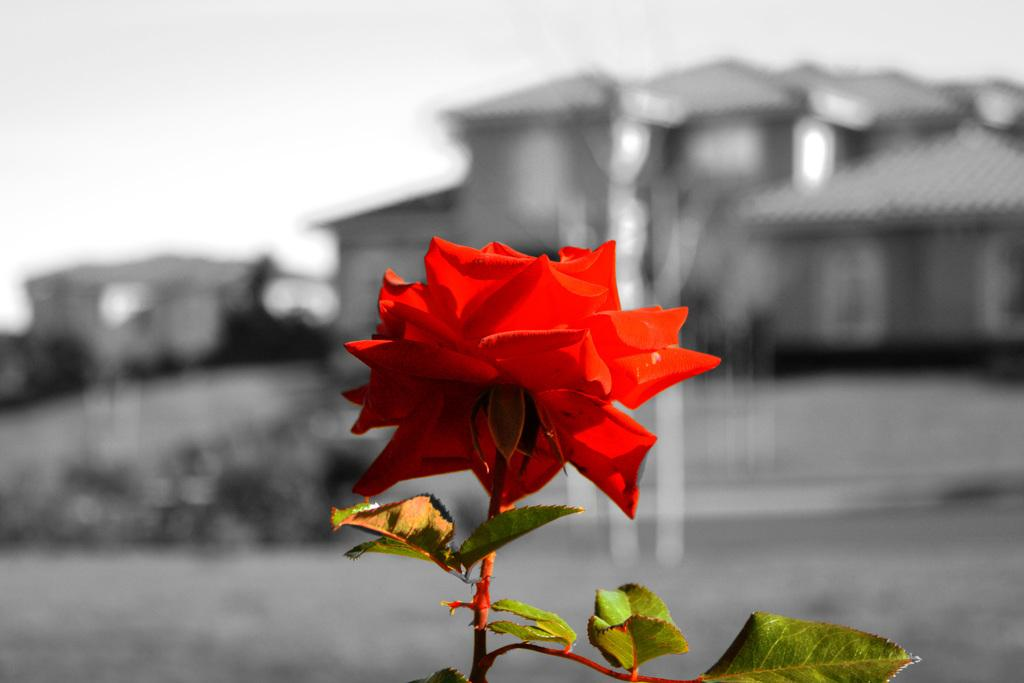What type of vegetation can be seen in the image? There are leaves in the image. What kind of flower is present in the image? There is a red color flower in the image. What can be seen in the distance in the image? There are houses in the background of the image. How would you describe the appearance of the background? The background appears blurry. What type of food is being served with a spoon in the image? There is no food or spoon present in the image; it features leaves, a red flower, houses in the background, and a blurry appearance. 